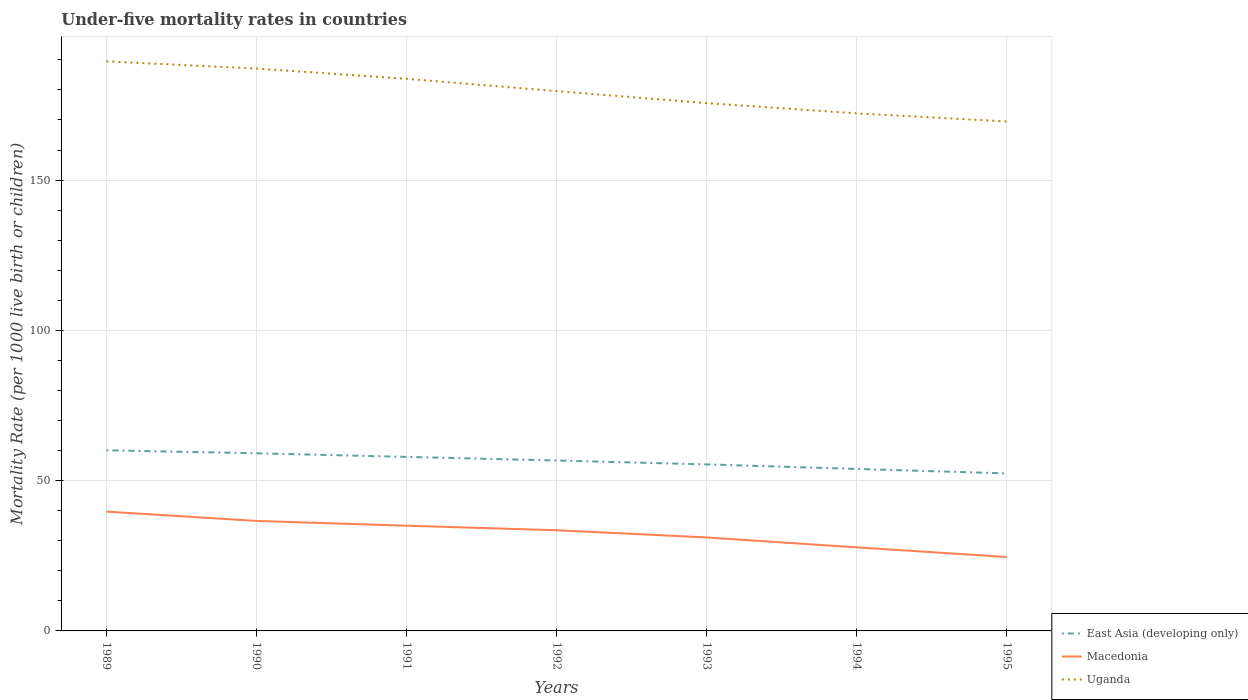Does the line corresponding to Macedonia intersect with the line corresponding to Uganda?
Offer a very short reply. No. Across all years, what is the maximum under-five mortality rate in Uganda?
Your answer should be very brief. 169.5. What is the total under-five mortality rate in East Asia (developing only) in the graph?
Keep it short and to the point. 2.2. What is the difference between the highest and the second highest under-five mortality rate in Macedonia?
Provide a short and direct response. 15.1. Is the under-five mortality rate in East Asia (developing only) strictly greater than the under-five mortality rate in Macedonia over the years?
Keep it short and to the point. No. How many lines are there?
Offer a very short reply. 3. How many years are there in the graph?
Ensure brevity in your answer.  7. What is the difference between two consecutive major ticks on the Y-axis?
Provide a succinct answer. 50. Are the values on the major ticks of Y-axis written in scientific E-notation?
Keep it short and to the point. No. How are the legend labels stacked?
Provide a short and direct response. Vertical. What is the title of the graph?
Give a very brief answer. Under-five mortality rates in countries. Does "Honduras" appear as one of the legend labels in the graph?
Offer a terse response. No. What is the label or title of the Y-axis?
Give a very brief answer. Mortality Rate (per 1000 live birth or children). What is the Mortality Rate (per 1000 live birth or children) in East Asia (developing only) in 1989?
Make the answer very short. 60.1. What is the Mortality Rate (per 1000 live birth or children) of Macedonia in 1989?
Offer a very short reply. 39.7. What is the Mortality Rate (per 1000 live birth or children) of Uganda in 1989?
Your response must be concise. 189.5. What is the Mortality Rate (per 1000 live birth or children) of East Asia (developing only) in 1990?
Provide a short and direct response. 59.1. What is the Mortality Rate (per 1000 live birth or children) of Macedonia in 1990?
Your answer should be compact. 36.6. What is the Mortality Rate (per 1000 live birth or children) in Uganda in 1990?
Provide a short and direct response. 187.1. What is the Mortality Rate (per 1000 live birth or children) of East Asia (developing only) in 1991?
Give a very brief answer. 57.9. What is the Mortality Rate (per 1000 live birth or children) in Macedonia in 1991?
Ensure brevity in your answer.  35. What is the Mortality Rate (per 1000 live birth or children) of Uganda in 1991?
Your response must be concise. 183.7. What is the Mortality Rate (per 1000 live birth or children) in East Asia (developing only) in 1992?
Offer a terse response. 56.7. What is the Mortality Rate (per 1000 live birth or children) of Macedonia in 1992?
Your answer should be very brief. 33.5. What is the Mortality Rate (per 1000 live birth or children) in Uganda in 1992?
Your answer should be very brief. 179.6. What is the Mortality Rate (per 1000 live birth or children) of East Asia (developing only) in 1993?
Keep it short and to the point. 55.4. What is the Mortality Rate (per 1000 live birth or children) in Macedonia in 1993?
Provide a short and direct response. 31.1. What is the Mortality Rate (per 1000 live birth or children) in Uganda in 1993?
Give a very brief answer. 175.6. What is the Mortality Rate (per 1000 live birth or children) of East Asia (developing only) in 1994?
Ensure brevity in your answer.  53.9. What is the Mortality Rate (per 1000 live birth or children) of Macedonia in 1994?
Provide a short and direct response. 27.8. What is the Mortality Rate (per 1000 live birth or children) in Uganda in 1994?
Your answer should be compact. 172.2. What is the Mortality Rate (per 1000 live birth or children) of East Asia (developing only) in 1995?
Offer a terse response. 52.4. What is the Mortality Rate (per 1000 live birth or children) of Macedonia in 1995?
Give a very brief answer. 24.6. What is the Mortality Rate (per 1000 live birth or children) of Uganda in 1995?
Your response must be concise. 169.5. Across all years, what is the maximum Mortality Rate (per 1000 live birth or children) of East Asia (developing only)?
Keep it short and to the point. 60.1. Across all years, what is the maximum Mortality Rate (per 1000 live birth or children) of Macedonia?
Provide a succinct answer. 39.7. Across all years, what is the maximum Mortality Rate (per 1000 live birth or children) in Uganda?
Keep it short and to the point. 189.5. Across all years, what is the minimum Mortality Rate (per 1000 live birth or children) in East Asia (developing only)?
Your response must be concise. 52.4. Across all years, what is the minimum Mortality Rate (per 1000 live birth or children) of Macedonia?
Provide a short and direct response. 24.6. Across all years, what is the minimum Mortality Rate (per 1000 live birth or children) in Uganda?
Ensure brevity in your answer.  169.5. What is the total Mortality Rate (per 1000 live birth or children) in East Asia (developing only) in the graph?
Provide a succinct answer. 395.5. What is the total Mortality Rate (per 1000 live birth or children) of Macedonia in the graph?
Ensure brevity in your answer.  228.3. What is the total Mortality Rate (per 1000 live birth or children) in Uganda in the graph?
Provide a succinct answer. 1257.2. What is the difference between the Mortality Rate (per 1000 live birth or children) of Macedonia in 1989 and that in 1991?
Make the answer very short. 4.7. What is the difference between the Mortality Rate (per 1000 live birth or children) in East Asia (developing only) in 1989 and that in 1992?
Provide a short and direct response. 3.4. What is the difference between the Mortality Rate (per 1000 live birth or children) of Macedonia in 1989 and that in 1992?
Provide a succinct answer. 6.2. What is the difference between the Mortality Rate (per 1000 live birth or children) of East Asia (developing only) in 1989 and that in 1993?
Ensure brevity in your answer.  4.7. What is the difference between the Mortality Rate (per 1000 live birth or children) of Macedonia in 1989 and that in 1993?
Keep it short and to the point. 8.6. What is the difference between the Mortality Rate (per 1000 live birth or children) in Uganda in 1989 and that in 1993?
Ensure brevity in your answer.  13.9. What is the difference between the Mortality Rate (per 1000 live birth or children) of Macedonia in 1989 and that in 1995?
Give a very brief answer. 15.1. What is the difference between the Mortality Rate (per 1000 live birth or children) of Macedonia in 1990 and that in 1991?
Your answer should be very brief. 1.6. What is the difference between the Mortality Rate (per 1000 live birth or children) in East Asia (developing only) in 1990 and that in 1992?
Make the answer very short. 2.4. What is the difference between the Mortality Rate (per 1000 live birth or children) in Macedonia in 1990 and that in 1992?
Keep it short and to the point. 3.1. What is the difference between the Mortality Rate (per 1000 live birth or children) in Uganda in 1990 and that in 1992?
Provide a succinct answer. 7.5. What is the difference between the Mortality Rate (per 1000 live birth or children) in East Asia (developing only) in 1990 and that in 1994?
Provide a succinct answer. 5.2. What is the difference between the Mortality Rate (per 1000 live birth or children) in Macedonia in 1990 and that in 1994?
Ensure brevity in your answer.  8.8. What is the difference between the Mortality Rate (per 1000 live birth or children) in Uganda in 1990 and that in 1995?
Offer a very short reply. 17.6. What is the difference between the Mortality Rate (per 1000 live birth or children) in Uganda in 1991 and that in 1992?
Make the answer very short. 4.1. What is the difference between the Mortality Rate (per 1000 live birth or children) of East Asia (developing only) in 1991 and that in 1993?
Your answer should be compact. 2.5. What is the difference between the Mortality Rate (per 1000 live birth or children) of East Asia (developing only) in 1991 and that in 1995?
Ensure brevity in your answer.  5.5. What is the difference between the Mortality Rate (per 1000 live birth or children) of Macedonia in 1991 and that in 1995?
Your answer should be compact. 10.4. What is the difference between the Mortality Rate (per 1000 live birth or children) in Uganda in 1991 and that in 1995?
Offer a terse response. 14.2. What is the difference between the Mortality Rate (per 1000 live birth or children) of East Asia (developing only) in 1992 and that in 1993?
Make the answer very short. 1.3. What is the difference between the Mortality Rate (per 1000 live birth or children) of Macedonia in 1992 and that in 1993?
Make the answer very short. 2.4. What is the difference between the Mortality Rate (per 1000 live birth or children) in Uganda in 1992 and that in 1994?
Offer a very short reply. 7.4. What is the difference between the Mortality Rate (per 1000 live birth or children) of East Asia (developing only) in 1993 and that in 1994?
Give a very brief answer. 1.5. What is the difference between the Mortality Rate (per 1000 live birth or children) of Macedonia in 1993 and that in 1994?
Make the answer very short. 3.3. What is the difference between the Mortality Rate (per 1000 live birth or children) in Uganda in 1993 and that in 1994?
Provide a short and direct response. 3.4. What is the difference between the Mortality Rate (per 1000 live birth or children) in Macedonia in 1993 and that in 1995?
Offer a terse response. 6.5. What is the difference between the Mortality Rate (per 1000 live birth or children) of Macedonia in 1994 and that in 1995?
Provide a succinct answer. 3.2. What is the difference between the Mortality Rate (per 1000 live birth or children) in Uganda in 1994 and that in 1995?
Keep it short and to the point. 2.7. What is the difference between the Mortality Rate (per 1000 live birth or children) in East Asia (developing only) in 1989 and the Mortality Rate (per 1000 live birth or children) in Uganda in 1990?
Make the answer very short. -127. What is the difference between the Mortality Rate (per 1000 live birth or children) of Macedonia in 1989 and the Mortality Rate (per 1000 live birth or children) of Uganda in 1990?
Offer a terse response. -147.4. What is the difference between the Mortality Rate (per 1000 live birth or children) in East Asia (developing only) in 1989 and the Mortality Rate (per 1000 live birth or children) in Macedonia in 1991?
Provide a short and direct response. 25.1. What is the difference between the Mortality Rate (per 1000 live birth or children) of East Asia (developing only) in 1989 and the Mortality Rate (per 1000 live birth or children) of Uganda in 1991?
Ensure brevity in your answer.  -123.6. What is the difference between the Mortality Rate (per 1000 live birth or children) of Macedonia in 1989 and the Mortality Rate (per 1000 live birth or children) of Uganda in 1991?
Ensure brevity in your answer.  -144. What is the difference between the Mortality Rate (per 1000 live birth or children) in East Asia (developing only) in 1989 and the Mortality Rate (per 1000 live birth or children) in Macedonia in 1992?
Offer a very short reply. 26.6. What is the difference between the Mortality Rate (per 1000 live birth or children) in East Asia (developing only) in 1989 and the Mortality Rate (per 1000 live birth or children) in Uganda in 1992?
Keep it short and to the point. -119.5. What is the difference between the Mortality Rate (per 1000 live birth or children) in Macedonia in 1989 and the Mortality Rate (per 1000 live birth or children) in Uganda in 1992?
Your answer should be very brief. -139.9. What is the difference between the Mortality Rate (per 1000 live birth or children) in East Asia (developing only) in 1989 and the Mortality Rate (per 1000 live birth or children) in Uganda in 1993?
Offer a terse response. -115.5. What is the difference between the Mortality Rate (per 1000 live birth or children) of Macedonia in 1989 and the Mortality Rate (per 1000 live birth or children) of Uganda in 1993?
Your answer should be very brief. -135.9. What is the difference between the Mortality Rate (per 1000 live birth or children) in East Asia (developing only) in 1989 and the Mortality Rate (per 1000 live birth or children) in Macedonia in 1994?
Your response must be concise. 32.3. What is the difference between the Mortality Rate (per 1000 live birth or children) of East Asia (developing only) in 1989 and the Mortality Rate (per 1000 live birth or children) of Uganda in 1994?
Give a very brief answer. -112.1. What is the difference between the Mortality Rate (per 1000 live birth or children) of Macedonia in 1989 and the Mortality Rate (per 1000 live birth or children) of Uganda in 1994?
Your answer should be very brief. -132.5. What is the difference between the Mortality Rate (per 1000 live birth or children) in East Asia (developing only) in 1989 and the Mortality Rate (per 1000 live birth or children) in Macedonia in 1995?
Make the answer very short. 35.5. What is the difference between the Mortality Rate (per 1000 live birth or children) in East Asia (developing only) in 1989 and the Mortality Rate (per 1000 live birth or children) in Uganda in 1995?
Offer a very short reply. -109.4. What is the difference between the Mortality Rate (per 1000 live birth or children) of Macedonia in 1989 and the Mortality Rate (per 1000 live birth or children) of Uganda in 1995?
Ensure brevity in your answer.  -129.8. What is the difference between the Mortality Rate (per 1000 live birth or children) of East Asia (developing only) in 1990 and the Mortality Rate (per 1000 live birth or children) of Macedonia in 1991?
Make the answer very short. 24.1. What is the difference between the Mortality Rate (per 1000 live birth or children) of East Asia (developing only) in 1990 and the Mortality Rate (per 1000 live birth or children) of Uganda in 1991?
Your answer should be compact. -124.6. What is the difference between the Mortality Rate (per 1000 live birth or children) in Macedonia in 1990 and the Mortality Rate (per 1000 live birth or children) in Uganda in 1991?
Offer a terse response. -147.1. What is the difference between the Mortality Rate (per 1000 live birth or children) of East Asia (developing only) in 1990 and the Mortality Rate (per 1000 live birth or children) of Macedonia in 1992?
Your response must be concise. 25.6. What is the difference between the Mortality Rate (per 1000 live birth or children) in East Asia (developing only) in 1990 and the Mortality Rate (per 1000 live birth or children) in Uganda in 1992?
Provide a succinct answer. -120.5. What is the difference between the Mortality Rate (per 1000 live birth or children) in Macedonia in 1990 and the Mortality Rate (per 1000 live birth or children) in Uganda in 1992?
Offer a terse response. -143. What is the difference between the Mortality Rate (per 1000 live birth or children) in East Asia (developing only) in 1990 and the Mortality Rate (per 1000 live birth or children) in Macedonia in 1993?
Offer a terse response. 28. What is the difference between the Mortality Rate (per 1000 live birth or children) of East Asia (developing only) in 1990 and the Mortality Rate (per 1000 live birth or children) of Uganda in 1993?
Your answer should be compact. -116.5. What is the difference between the Mortality Rate (per 1000 live birth or children) of Macedonia in 1990 and the Mortality Rate (per 1000 live birth or children) of Uganda in 1993?
Ensure brevity in your answer.  -139. What is the difference between the Mortality Rate (per 1000 live birth or children) in East Asia (developing only) in 1990 and the Mortality Rate (per 1000 live birth or children) in Macedonia in 1994?
Give a very brief answer. 31.3. What is the difference between the Mortality Rate (per 1000 live birth or children) of East Asia (developing only) in 1990 and the Mortality Rate (per 1000 live birth or children) of Uganda in 1994?
Your response must be concise. -113.1. What is the difference between the Mortality Rate (per 1000 live birth or children) in Macedonia in 1990 and the Mortality Rate (per 1000 live birth or children) in Uganda in 1994?
Make the answer very short. -135.6. What is the difference between the Mortality Rate (per 1000 live birth or children) of East Asia (developing only) in 1990 and the Mortality Rate (per 1000 live birth or children) of Macedonia in 1995?
Provide a short and direct response. 34.5. What is the difference between the Mortality Rate (per 1000 live birth or children) of East Asia (developing only) in 1990 and the Mortality Rate (per 1000 live birth or children) of Uganda in 1995?
Keep it short and to the point. -110.4. What is the difference between the Mortality Rate (per 1000 live birth or children) in Macedonia in 1990 and the Mortality Rate (per 1000 live birth or children) in Uganda in 1995?
Your answer should be very brief. -132.9. What is the difference between the Mortality Rate (per 1000 live birth or children) in East Asia (developing only) in 1991 and the Mortality Rate (per 1000 live birth or children) in Macedonia in 1992?
Give a very brief answer. 24.4. What is the difference between the Mortality Rate (per 1000 live birth or children) in East Asia (developing only) in 1991 and the Mortality Rate (per 1000 live birth or children) in Uganda in 1992?
Make the answer very short. -121.7. What is the difference between the Mortality Rate (per 1000 live birth or children) in Macedonia in 1991 and the Mortality Rate (per 1000 live birth or children) in Uganda in 1992?
Offer a terse response. -144.6. What is the difference between the Mortality Rate (per 1000 live birth or children) in East Asia (developing only) in 1991 and the Mortality Rate (per 1000 live birth or children) in Macedonia in 1993?
Make the answer very short. 26.8. What is the difference between the Mortality Rate (per 1000 live birth or children) in East Asia (developing only) in 1991 and the Mortality Rate (per 1000 live birth or children) in Uganda in 1993?
Offer a very short reply. -117.7. What is the difference between the Mortality Rate (per 1000 live birth or children) of Macedonia in 1991 and the Mortality Rate (per 1000 live birth or children) of Uganda in 1993?
Give a very brief answer. -140.6. What is the difference between the Mortality Rate (per 1000 live birth or children) of East Asia (developing only) in 1991 and the Mortality Rate (per 1000 live birth or children) of Macedonia in 1994?
Keep it short and to the point. 30.1. What is the difference between the Mortality Rate (per 1000 live birth or children) in East Asia (developing only) in 1991 and the Mortality Rate (per 1000 live birth or children) in Uganda in 1994?
Make the answer very short. -114.3. What is the difference between the Mortality Rate (per 1000 live birth or children) of Macedonia in 1991 and the Mortality Rate (per 1000 live birth or children) of Uganda in 1994?
Make the answer very short. -137.2. What is the difference between the Mortality Rate (per 1000 live birth or children) in East Asia (developing only) in 1991 and the Mortality Rate (per 1000 live birth or children) in Macedonia in 1995?
Offer a terse response. 33.3. What is the difference between the Mortality Rate (per 1000 live birth or children) in East Asia (developing only) in 1991 and the Mortality Rate (per 1000 live birth or children) in Uganda in 1995?
Keep it short and to the point. -111.6. What is the difference between the Mortality Rate (per 1000 live birth or children) in Macedonia in 1991 and the Mortality Rate (per 1000 live birth or children) in Uganda in 1995?
Give a very brief answer. -134.5. What is the difference between the Mortality Rate (per 1000 live birth or children) of East Asia (developing only) in 1992 and the Mortality Rate (per 1000 live birth or children) of Macedonia in 1993?
Make the answer very short. 25.6. What is the difference between the Mortality Rate (per 1000 live birth or children) in East Asia (developing only) in 1992 and the Mortality Rate (per 1000 live birth or children) in Uganda in 1993?
Ensure brevity in your answer.  -118.9. What is the difference between the Mortality Rate (per 1000 live birth or children) of Macedonia in 1992 and the Mortality Rate (per 1000 live birth or children) of Uganda in 1993?
Provide a succinct answer. -142.1. What is the difference between the Mortality Rate (per 1000 live birth or children) in East Asia (developing only) in 1992 and the Mortality Rate (per 1000 live birth or children) in Macedonia in 1994?
Offer a very short reply. 28.9. What is the difference between the Mortality Rate (per 1000 live birth or children) in East Asia (developing only) in 1992 and the Mortality Rate (per 1000 live birth or children) in Uganda in 1994?
Offer a terse response. -115.5. What is the difference between the Mortality Rate (per 1000 live birth or children) in Macedonia in 1992 and the Mortality Rate (per 1000 live birth or children) in Uganda in 1994?
Offer a very short reply. -138.7. What is the difference between the Mortality Rate (per 1000 live birth or children) in East Asia (developing only) in 1992 and the Mortality Rate (per 1000 live birth or children) in Macedonia in 1995?
Keep it short and to the point. 32.1. What is the difference between the Mortality Rate (per 1000 live birth or children) in East Asia (developing only) in 1992 and the Mortality Rate (per 1000 live birth or children) in Uganda in 1995?
Make the answer very short. -112.8. What is the difference between the Mortality Rate (per 1000 live birth or children) in Macedonia in 1992 and the Mortality Rate (per 1000 live birth or children) in Uganda in 1995?
Provide a short and direct response. -136. What is the difference between the Mortality Rate (per 1000 live birth or children) in East Asia (developing only) in 1993 and the Mortality Rate (per 1000 live birth or children) in Macedonia in 1994?
Provide a succinct answer. 27.6. What is the difference between the Mortality Rate (per 1000 live birth or children) in East Asia (developing only) in 1993 and the Mortality Rate (per 1000 live birth or children) in Uganda in 1994?
Offer a very short reply. -116.8. What is the difference between the Mortality Rate (per 1000 live birth or children) of Macedonia in 1993 and the Mortality Rate (per 1000 live birth or children) of Uganda in 1994?
Make the answer very short. -141.1. What is the difference between the Mortality Rate (per 1000 live birth or children) in East Asia (developing only) in 1993 and the Mortality Rate (per 1000 live birth or children) in Macedonia in 1995?
Give a very brief answer. 30.8. What is the difference between the Mortality Rate (per 1000 live birth or children) of East Asia (developing only) in 1993 and the Mortality Rate (per 1000 live birth or children) of Uganda in 1995?
Offer a very short reply. -114.1. What is the difference between the Mortality Rate (per 1000 live birth or children) in Macedonia in 1993 and the Mortality Rate (per 1000 live birth or children) in Uganda in 1995?
Give a very brief answer. -138.4. What is the difference between the Mortality Rate (per 1000 live birth or children) in East Asia (developing only) in 1994 and the Mortality Rate (per 1000 live birth or children) in Macedonia in 1995?
Give a very brief answer. 29.3. What is the difference between the Mortality Rate (per 1000 live birth or children) of East Asia (developing only) in 1994 and the Mortality Rate (per 1000 live birth or children) of Uganda in 1995?
Provide a short and direct response. -115.6. What is the difference between the Mortality Rate (per 1000 live birth or children) of Macedonia in 1994 and the Mortality Rate (per 1000 live birth or children) of Uganda in 1995?
Your answer should be very brief. -141.7. What is the average Mortality Rate (per 1000 live birth or children) of East Asia (developing only) per year?
Your response must be concise. 56.5. What is the average Mortality Rate (per 1000 live birth or children) in Macedonia per year?
Keep it short and to the point. 32.61. What is the average Mortality Rate (per 1000 live birth or children) in Uganda per year?
Provide a succinct answer. 179.6. In the year 1989, what is the difference between the Mortality Rate (per 1000 live birth or children) in East Asia (developing only) and Mortality Rate (per 1000 live birth or children) in Macedonia?
Provide a short and direct response. 20.4. In the year 1989, what is the difference between the Mortality Rate (per 1000 live birth or children) in East Asia (developing only) and Mortality Rate (per 1000 live birth or children) in Uganda?
Your answer should be compact. -129.4. In the year 1989, what is the difference between the Mortality Rate (per 1000 live birth or children) in Macedonia and Mortality Rate (per 1000 live birth or children) in Uganda?
Provide a short and direct response. -149.8. In the year 1990, what is the difference between the Mortality Rate (per 1000 live birth or children) of East Asia (developing only) and Mortality Rate (per 1000 live birth or children) of Uganda?
Give a very brief answer. -128. In the year 1990, what is the difference between the Mortality Rate (per 1000 live birth or children) in Macedonia and Mortality Rate (per 1000 live birth or children) in Uganda?
Offer a terse response. -150.5. In the year 1991, what is the difference between the Mortality Rate (per 1000 live birth or children) of East Asia (developing only) and Mortality Rate (per 1000 live birth or children) of Macedonia?
Your answer should be very brief. 22.9. In the year 1991, what is the difference between the Mortality Rate (per 1000 live birth or children) of East Asia (developing only) and Mortality Rate (per 1000 live birth or children) of Uganda?
Your response must be concise. -125.8. In the year 1991, what is the difference between the Mortality Rate (per 1000 live birth or children) in Macedonia and Mortality Rate (per 1000 live birth or children) in Uganda?
Keep it short and to the point. -148.7. In the year 1992, what is the difference between the Mortality Rate (per 1000 live birth or children) of East Asia (developing only) and Mortality Rate (per 1000 live birth or children) of Macedonia?
Your answer should be compact. 23.2. In the year 1992, what is the difference between the Mortality Rate (per 1000 live birth or children) in East Asia (developing only) and Mortality Rate (per 1000 live birth or children) in Uganda?
Provide a succinct answer. -122.9. In the year 1992, what is the difference between the Mortality Rate (per 1000 live birth or children) of Macedonia and Mortality Rate (per 1000 live birth or children) of Uganda?
Make the answer very short. -146.1. In the year 1993, what is the difference between the Mortality Rate (per 1000 live birth or children) in East Asia (developing only) and Mortality Rate (per 1000 live birth or children) in Macedonia?
Provide a short and direct response. 24.3. In the year 1993, what is the difference between the Mortality Rate (per 1000 live birth or children) in East Asia (developing only) and Mortality Rate (per 1000 live birth or children) in Uganda?
Provide a short and direct response. -120.2. In the year 1993, what is the difference between the Mortality Rate (per 1000 live birth or children) of Macedonia and Mortality Rate (per 1000 live birth or children) of Uganda?
Your answer should be compact. -144.5. In the year 1994, what is the difference between the Mortality Rate (per 1000 live birth or children) in East Asia (developing only) and Mortality Rate (per 1000 live birth or children) in Macedonia?
Make the answer very short. 26.1. In the year 1994, what is the difference between the Mortality Rate (per 1000 live birth or children) in East Asia (developing only) and Mortality Rate (per 1000 live birth or children) in Uganda?
Your response must be concise. -118.3. In the year 1994, what is the difference between the Mortality Rate (per 1000 live birth or children) in Macedonia and Mortality Rate (per 1000 live birth or children) in Uganda?
Offer a very short reply. -144.4. In the year 1995, what is the difference between the Mortality Rate (per 1000 live birth or children) in East Asia (developing only) and Mortality Rate (per 1000 live birth or children) in Macedonia?
Your answer should be very brief. 27.8. In the year 1995, what is the difference between the Mortality Rate (per 1000 live birth or children) in East Asia (developing only) and Mortality Rate (per 1000 live birth or children) in Uganda?
Provide a succinct answer. -117.1. In the year 1995, what is the difference between the Mortality Rate (per 1000 live birth or children) of Macedonia and Mortality Rate (per 1000 live birth or children) of Uganda?
Your response must be concise. -144.9. What is the ratio of the Mortality Rate (per 1000 live birth or children) in East Asia (developing only) in 1989 to that in 1990?
Your response must be concise. 1.02. What is the ratio of the Mortality Rate (per 1000 live birth or children) of Macedonia in 1989 to that in 1990?
Offer a terse response. 1.08. What is the ratio of the Mortality Rate (per 1000 live birth or children) in Uganda in 1989 to that in 1990?
Provide a succinct answer. 1.01. What is the ratio of the Mortality Rate (per 1000 live birth or children) in East Asia (developing only) in 1989 to that in 1991?
Your answer should be compact. 1.04. What is the ratio of the Mortality Rate (per 1000 live birth or children) in Macedonia in 1989 to that in 1991?
Your response must be concise. 1.13. What is the ratio of the Mortality Rate (per 1000 live birth or children) in Uganda in 1989 to that in 1991?
Your answer should be compact. 1.03. What is the ratio of the Mortality Rate (per 1000 live birth or children) of East Asia (developing only) in 1989 to that in 1992?
Keep it short and to the point. 1.06. What is the ratio of the Mortality Rate (per 1000 live birth or children) of Macedonia in 1989 to that in 1992?
Your answer should be very brief. 1.19. What is the ratio of the Mortality Rate (per 1000 live birth or children) of Uganda in 1989 to that in 1992?
Your answer should be compact. 1.06. What is the ratio of the Mortality Rate (per 1000 live birth or children) of East Asia (developing only) in 1989 to that in 1993?
Make the answer very short. 1.08. What is the ratio of the Mortality Rate (per 1000 live birth or children) of Macedonia in 1989 to that in 1993?
Give a very brief answer. 1.28. What is the ratio of the Mortality Rate (per 1000 live birth or children) in Uganda in 1989 to that in 1993?
Make the answer very short. 1.08. What is the ratio of the Mortality Rate (per 1000 live birth or children) of East Asia (developing only) in 1989 to that in 1994?
Offer a very short reply. 1.11. What is the ratio of the Mortality Rate (per 1000 live birth or children) of Macedonia in 1989 to that in 1994?
Offer a terse response. 1.43. What is the ratio of the Mortality Rate (per 1000 live birth or children) in Uganda in 1989 to that in 1994?
Your response must be concise. 1.1. What is the ratio of the Mortality Rate (per 1000 live birth or children) in East Asia (developing only) in 1989 to that in 1995?
Provide a short and direct response. 1.15. What is the ratio of the Mortality Rate (per 1000 live birth or children) in Macedonia in 1989 to that in 1995?
Keep it short and to the point. 1.61. What is the ratio of the Mortality Rate (per 1000 live birth or children) in Uganda in 1989 to that in 1995?
Offer a very short reply. 1.12. What is the ratio of the Mortality Rate (per 1000 live birth or children) of East Asia (developing only) in 1990 to that in 1991?
Ensure brevity in your answer.  1.02. What is the ratio of the Mortality Rate (per 1000 live birth or children) of Macedonia in 1990 to that in 1991?
Provide a succinct answer. 1.05. What is the ratio of the Mortality Rate (per 1000 live birth or children) in Uganda in 1990 to that in 1991?
Your response must be concise. 1.02. What is the ratio of the Mortality Rate (per 1000 live birth or children) in East Asia (developing only) in 1990 to that in 1992?
Provide a short and direct response. 1.04. What is the ratio of the Mortality Rate (per 1000 live birth or children) in Macedonia in 1990 to that in 1992?
Ensure brevity in your answer.  1.09. What is the ratio of the Mortality Rate (per 1000 live birth or children) of Uganda in 1990 to that in 1992?
Make the answer very short. 1.04. What is the ratio of the Mortality Rate (per 1000 live birth or children) in East Asia (developing only) in 1990 to that in 1993?
Provide a succinct answer. 1.07. What is the ratio of the Mortality Rate (per 1000 live birth or children) of Macedonia in 1990 to that in 1993?
Provide a short and direct response. 1.18. What is the ratio of the Mortality Rate (per 1000 live birth or children) in Uganda in 1990 to that in 1993?
Give a very brief answer. 1.07. What is the ratio of the Mortality Rate (per 1000 live birth or children) of East Asia (developing only) in 1990 to that in 1994?
Offer a very short reply. 1.1. What is the ratio of the Mortality Rate (per 1000 live birth or children) in Macedonia in 1990 to that in 1994?
Make the answer very short. 1.32. What is the ratio of the Mortality Rate (per 1000 live birth or children) of Uganda in 1990 to that in 1994?
Offer a terse response. 1.09. What is the ratio of the Mortality Rate (per 1000 live birth or children) of East Asia (developing only) in 1990 to that in 1995?
Offer a very short reply. 1.13. What is the ratio of the Mortality Rate (per 1000 live birth or children) in Macedonia in 1990 to that in 1995?
Provide a short and direct response. 1.49. What is the ratio of the Mortality Rate (per 1000 live birth or children) in Uganda in 1990 to that in 1995?
Offer a very short reply. 1.1. What is the ratio of the Mortality Rate (per 1000 live birth or children) in East Asia (developing only) in 1991 to that in 1992?
Make the answer very short. 1.02. What is the ratio of the Mortality Rate (per 1000 live birth or children) in Macedonia in 1991 to that in 1992?
Offer a very short reply. 1.04. What is the ratio of the Mortality Rate (per 1000 live birth or children) in Uganda in 1991 to that in 1992?
Make the answer very short. 1.02. What is the ratio of the Mortality Rate (per 1000 live birth or children) of East Asia (developing only) in 1991 to that in 1993?
Offer a terse response. 1.05. What is the ratio of the Mortality Rate (per 1000 live birth or children) in Macedonia in 1991 to that in 1993?
Make the answer very short. 1.13. What is the ratio of the Mortality Rate (per 1000 live birth or children) of Uganda in 1991 to that in 1993?
Ensure brevity in your answer.  1.05. What is the ratio of the Mortality Rate (per 1000 live birth or children) of East Asia (developing only) in 1991 to that in 1994?
Give a very brief answer. 1.07. What is the ratio of the Mortality Rate (per 1000 live birth or children) of Macedonia in 1991 to that in 1994?
Make the answer very short. 1.26. What is the ratio of the Mortality Rate (per 1000 live birth or children) of Uganda in 1991 to that in 1994?
Ensure brevity in your answer.  1.07. What is the ratio of the Mortality Rate (per 1000 live birth or children) of East Asia (developing only) in 1991 to that in 1995?
Provide a short and direct response. 1.1. What is the ratio of the Mortality Rate (per 1000 live birth or children) in Macedonia in 1991 to that in 1995?
Make the answer very short. 1.42. What is the ratio of the Mortality Rate (per 1000 live birth or children) in Uganda in 1991 to that in 1995?
Keep it short and to the point. 1.08. What is the ratio of the Mortality Rate (per 1000 live birth or children) of East Asia (developing only) in 1992 to that in 1993?
Provide a succinct answer. 1.02. What is the ratio of the Mortality Rate (per 1000 live birth or children) in Macedonia in 1992 to that in 1993?
Ensure brevity in your answer.  1.08. What is the ratio of the Mortality Rate (per 1000 live birth or children) in Uganda in 1992 to that in 1993?
Offer a terse response. 1.02. What is the ratio of the Mortality Rate (per 1000 live birth or children) in East Asia (developing only) in 1992 to that in 1994?
Offer a very short reply. 1.05. What is the ratio of the Mortality Rate (per 1000 live birth or children) of Macedonia in 1992 to that in 1994?
Provide a short and direct response. 1.21. What is the ratio of the Mortality Rate (per 1000 live birth or children) of Uganda in 1992 to that in 1994?
Your response must be concise. 1.04. What is the ratio of the Mortality Rate (per 1000 live birth or children) of East Asia (developing only) in 1992 to that in 1995?
Your answer should be very brief. 1.08. What is the ratio of the Mortality Rate (per 1000 live birth or children) of Macedonia in 1992 to that in 1995?
Ensure brevity in your answer.  1.36. What is the ratio of the Mortality Rate (per 1000 live birth or children) of Uganda in 1992 to that in 1995?
Provide a succinct answer. 1.06. What is the ratio of the Mortality Rate (per 1000 live birth or children) in East Asia (developing only) in 1993 to that in 1994?
Provide a short and direct response. 1.03. What is the ratio of the Mortality Rate (per 1000 live birth or children) of Macedonia in 1993 to that in 1994?
Keep it short and to the point. 1.12. What is the ratio of the Mortality Rate (per 1000 live birth or children) of Uganda in 1993 to that in 1994?
Ensure brevity in your answer.  1.02. What is the ratio of the Mortality Rate (per 1000 live birth or children) in East Asia (developing only) in 1993 to that in 1995?
Your answer should be very brief. 1.06. What is the ratio of the Mortality Rate (per 1000 live birth or children) in Macedonia in 1993 to that in 1995?
Your response must be concise. 1.26. What is the ratio of the Mortality Rate (per 1000 live birth or children) in Uganda in 1993 to that in 1995?
Offer a very short reply. 1.04. What is the ratio of the Mortality Rate (per 1000 live birth or children) of East Asia (developing only) in 1994 to that in 1995?
Offer a terse response. 1.03. What is the ratio of the Mortality Rate (per 1000 live birth or children) of Macedonia in 1994 to that in 1995?
Your response must be concise. 1.13. What is the ratio of the Mortality Rate (per 1000 live birth or children) of Uganda in 1994 to that in 1995?
Make the answer very short. 1.02. What is the difference between the highest and the second highest Mortality Rate (per 1000 live birth or children) of Uganda?
Offer a terse response. 2.4. What is the difference between the highest and the lowest Mortality Rate (per 1000 live birth or children) in Uganda?
Ensure brevity in your answer.  20. 